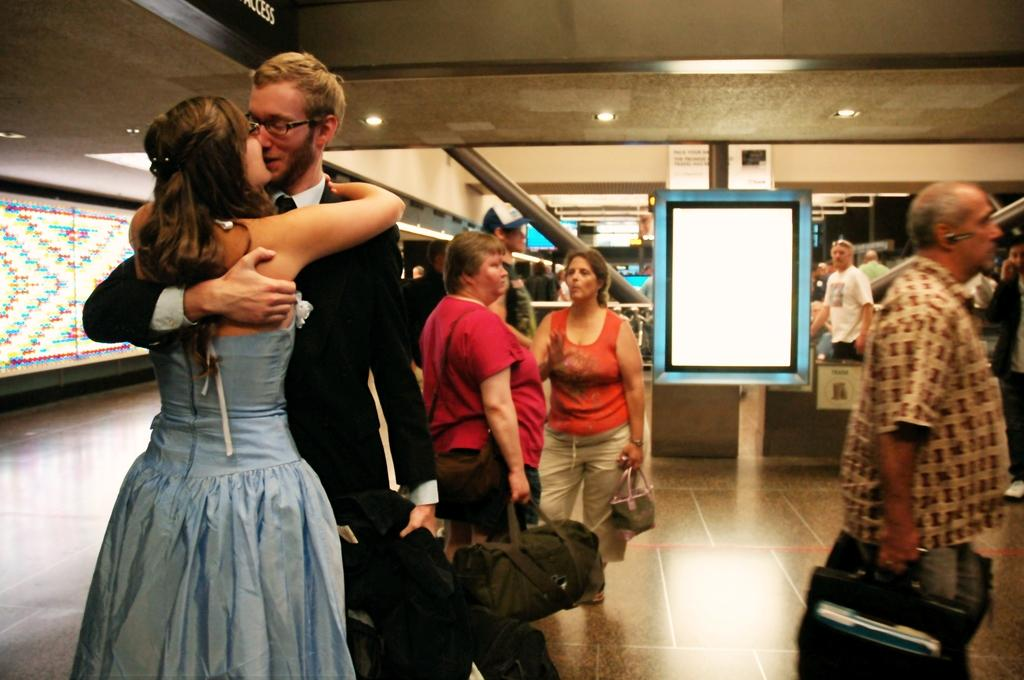Who or what can be seen in the image? There are people in the image. What is the surface beneath the people? The ground is visible in the image. What is the background of the image made of? There is a wall in the image. What objects are present in the image that are made of wood? There are boards in the image. What vertical structures can be seen in the image? There are poles in the image. What is covering the top of the structure in the image? The roof is visible in the image. What is illuminating the area in the image? There are lights on the roof. What type of knee can be seen on the wall in the image? There is no knee present in the image; it is a wall made of bricks or other materials. 